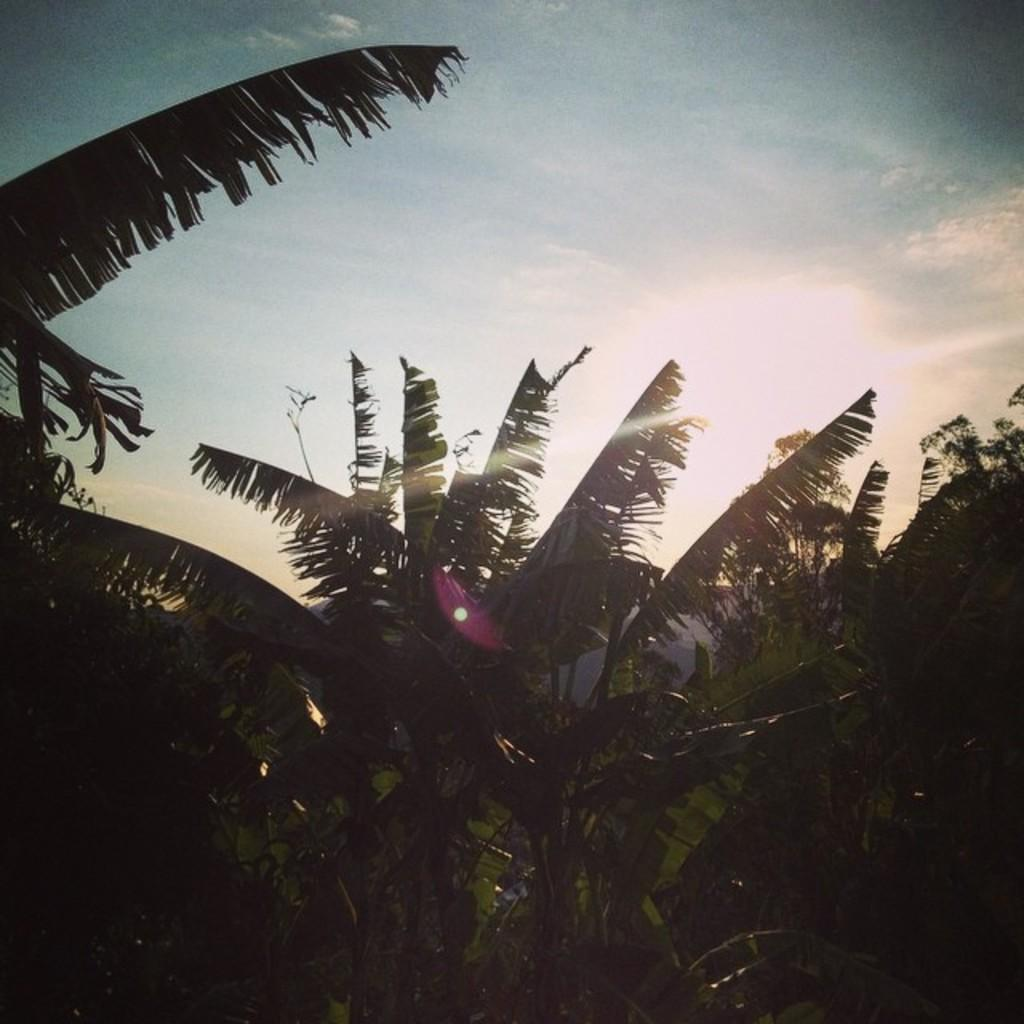What type of vegetation can be seen in the image? There are trees in the image. What part of the natural environment is visible in the image? The sky is visible in the image. How many tomatoes can be seen floating in the sky in the image? There are no tomatoes present in the image, and they cannot float in the sky. 